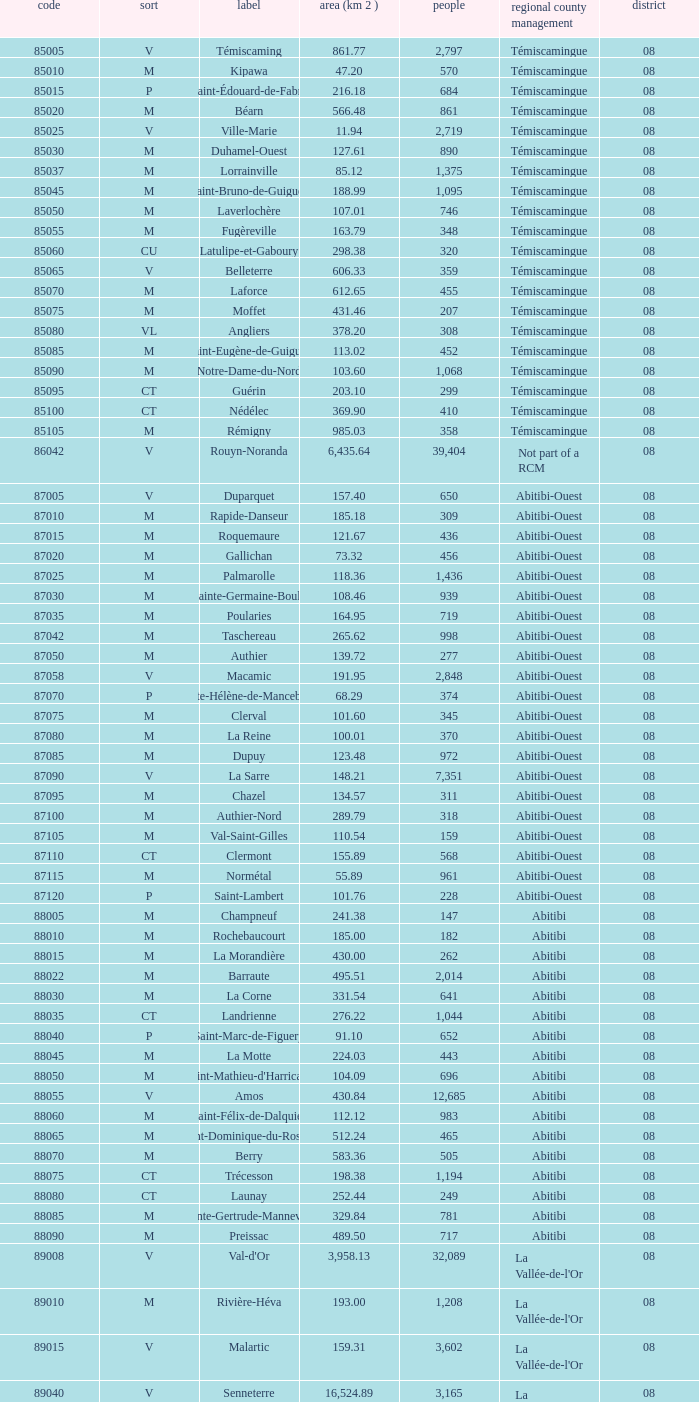What municipality has 719 people and is larger than 108.46 km2? Abitibi-Ouest. 